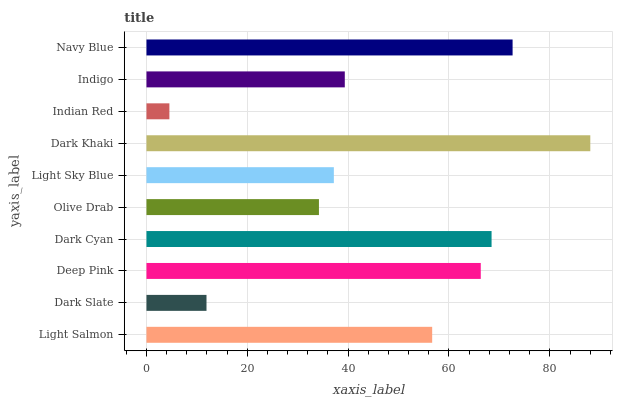Is Indian Red the minimum?
Answer yes or no. Yes. Is Dark Khaki the maximum?
Answer yes or no. Yes. Is Dark Slate the minimum?
Answer yes or no. No. Is Dark Slate the maximum?
Answer yes or no. No. Is Light Salmon greater than Dark Slate?
Answer yes or no. Yes. Is Dark Slate less than Light Salmon?
Answer yes or no. Yes. Is Dark Slate greater than Light Salmon?
Answer yes or no. No. Is Light Salmon less than Dark Slate?
Answer yes or no. No. Is Light Salmon the high median?
Answer yes or no. Yes. Is Indigo the low median?
Answer yes or no. Yes. Is Navy Blue the high median?
Answer yes or no. No. Is Dark Khaki the low median?
Answer yes or no. No. 